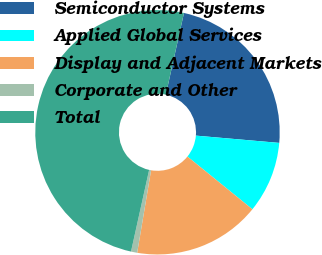Convert chart to OTSL. <chart><loc_0><loc_0><loc_500><loc_500><pie_chart><fcel>Semiconductor Systems<fcel>Applied Global Services<fcel>Display and Adjacent Markets<fcel>Corporate and Other<fcel>Total<nl><fcel>22.91%<fcel>9.46%<fcel>16.81%<fcel>0.82%<fcel>50.0%<nl></chart> 